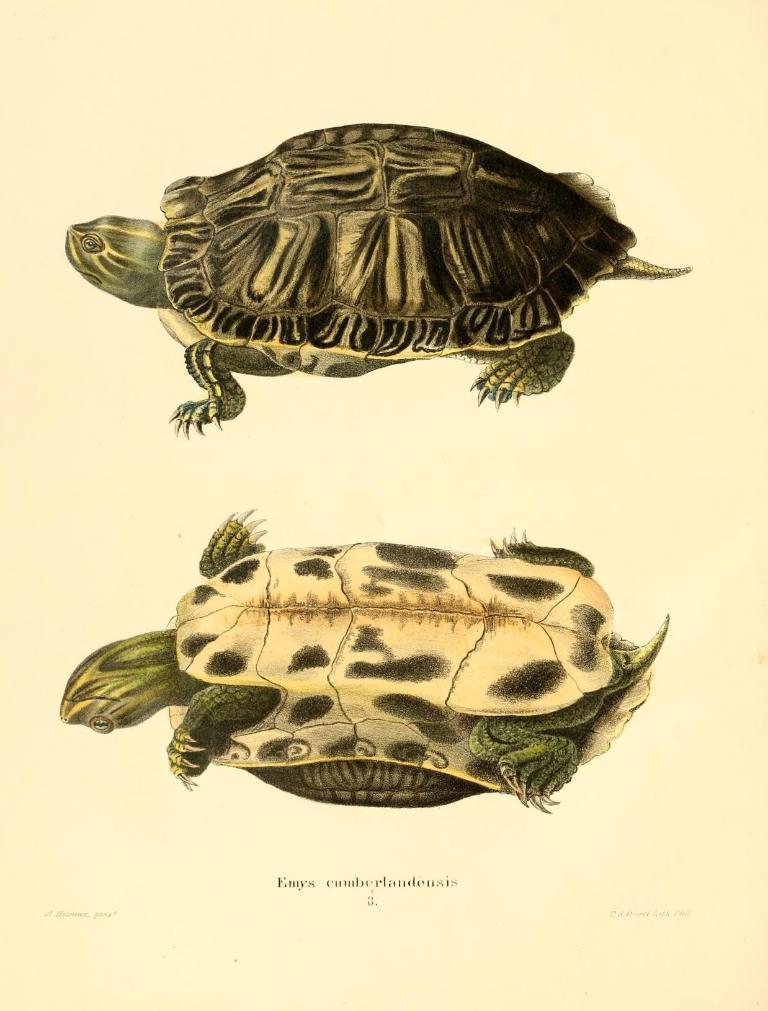Describe this image in one or two sentences. In this picture I can see the depiction of 2 turtles and I see something is written on the bottom side of this picture. 